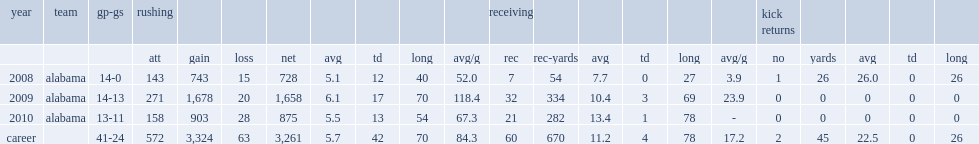How many receiving yards did ingram jr get in 2010? 282.0. 